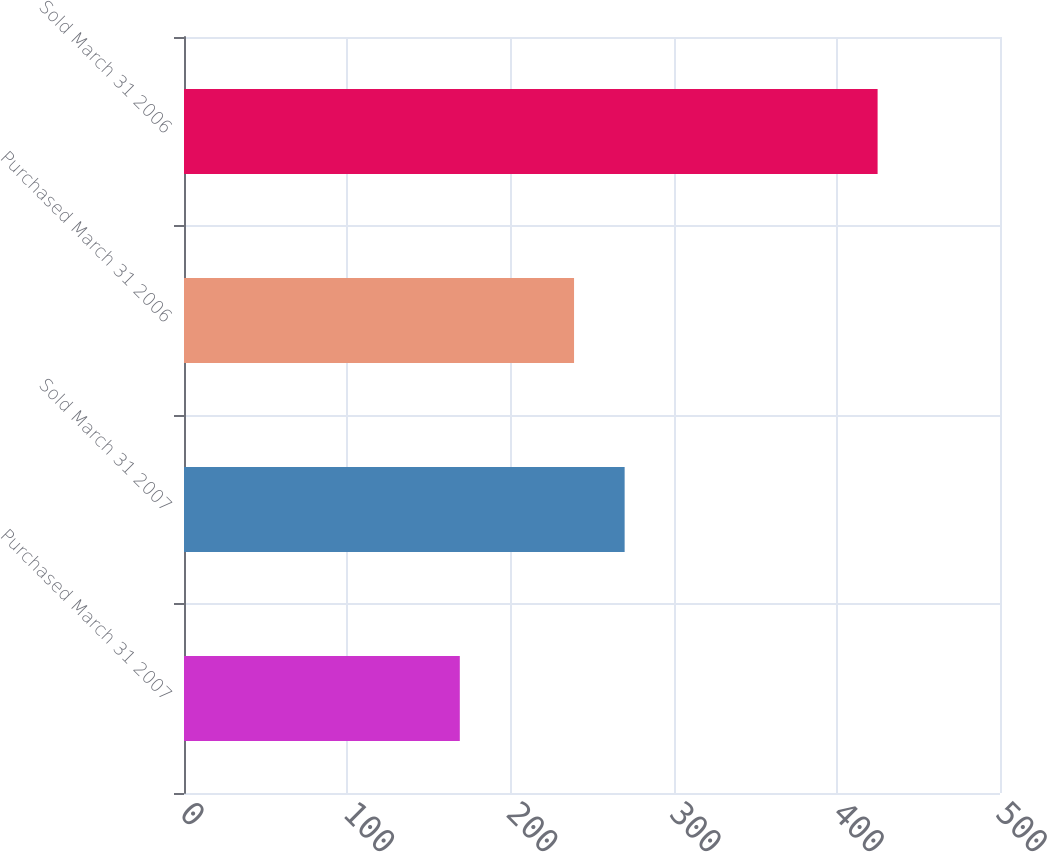Convert chart to OTSL. <chart><loc_0><loc_0><loc_500><loc_500><bar_chart><fcel>Purchased March 31 2007<fcel>Sold March 31 2007<fcel>Purchased March 31 2006<fcel>Sold March 31 2006<nl><fcel>169<fcel>270<fcel>239<fcel>425<nl></chart> 